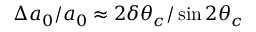Convert formula to latex. <formula><loc_0><loc_0><loc_500><loc_500>\Delta a _ { 0 } / a _ { 0 } \approx 2 \delta \theta _ { c } / \sin { 2 \theta _ { c } }</formula> 